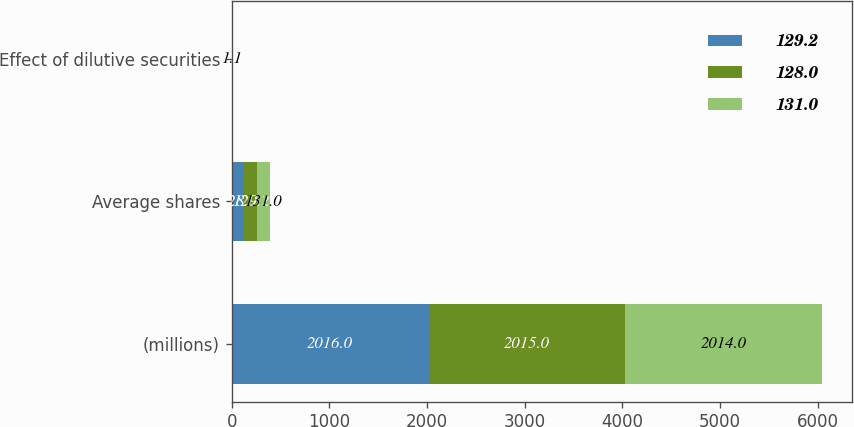Convert chart to OTSL. <chart><loc_0><loc_0><loc_500><loc_500><stacked_bar_chart><ecel><fcel>(millions)<fcel>Average shares<fcel>Effect of dilutive securities<nl><fcel>129.2<fcel>2016<fcel>128<fcel>1.4<nl><fcel>128<fcel>2015<fcel>129.2<fcel>1.2<nl><fcel>131<fcel>2014<fcel>131<fcel>1.1<nl></chart> 